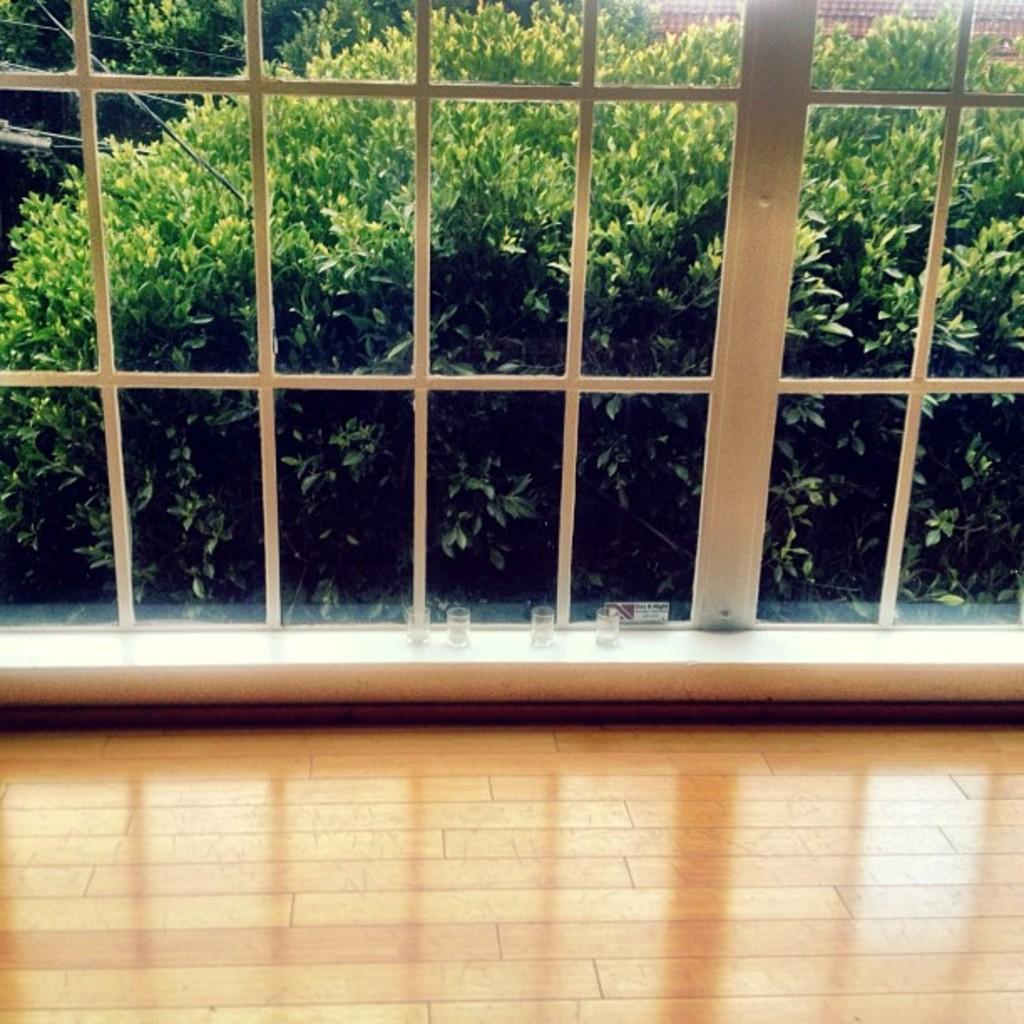How would you summarize this image in a sentence or two? In the center of the image there is a window and we can see bushes through the window. 